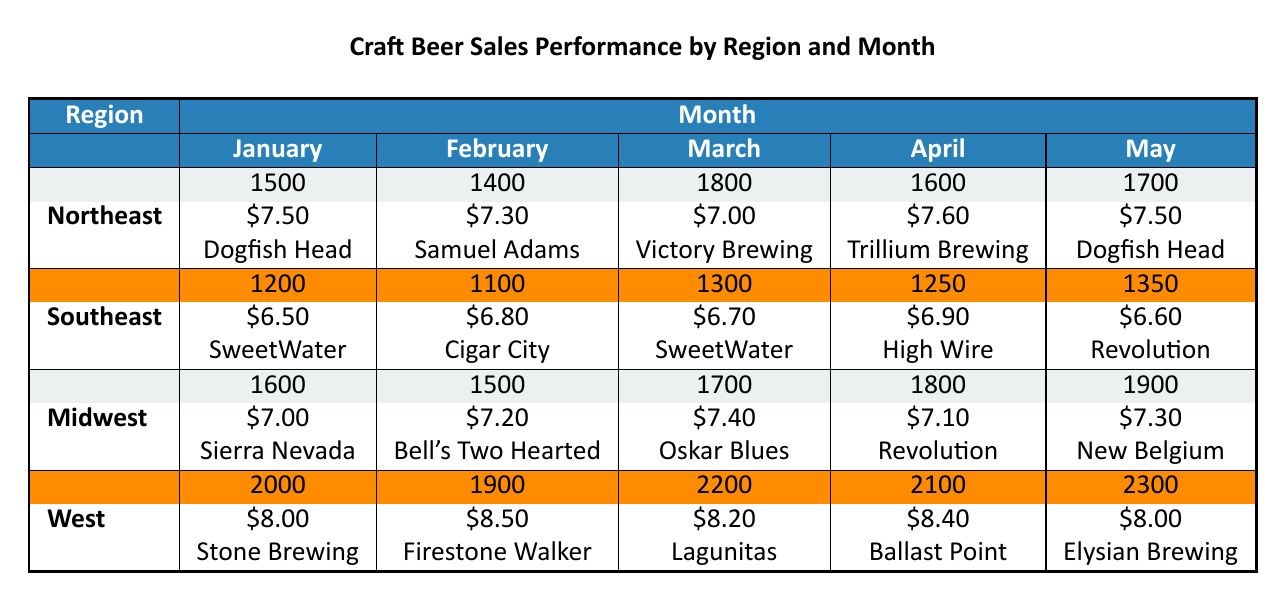What was the highest sales volume in March and which region achieved it? In March, the region with the highest sales volume is the West with a sales volume of 2200.
Answer: West, 2200 What brand had the highest average price in April? In April, the West region had the highest average price of $8.40 with the top brand being Ballast Point.
Answer: Ballast Point How many total craft beer sales were recorded in the Midwest from January to May? Adding the sales volumes from the Midwest for each month: 1600 + 1500 + 1700 + 1800 + 1900 = 10500.
Answer: 10500 Which region had the lowest sales volume in February and what was that volume? In February, the Southeast had the lowest sales volume at 1100.
Answer: Southeast, 1100 Is the average price of craft beers in the Northeast region consistent across all months? The average prices in the Northeast are $7.50, $7.30, $7.00, $7.60, and $7.50, which shows variation, so it is not consistent.
Answer: No What is the average sales volume for the West region across the five months provided? The total sales volume for the West is 2000 + 1900 + 2200 + 2100 + 2300 = 11500, and dividing by 5 gives an average of 2300.
Answer: 2300 Which brand is consistently present as a top brand in January and May in the Northeast? Dogfish Head appears as a top brand in both January and May for the Northeast.
Answer: Dogfish Head Did the sales volume in the Southeast increase or decrease from January to May? The sales volume decreased from 1200 in January to 1350 in May.
Answer: Increase How does the average price of craft beers in the Midwest compare to the West in March? In March, the average price in the Midwest was $7.40 while in the West it was $8.20, indicating the West is more expensive.
Answer: West is more expensive What was the total sales volume for all regions in April? Summing the sales volumes in April gives 1600 + 1250 + 1800 + 2100 = 8800.
Answer: 8800 